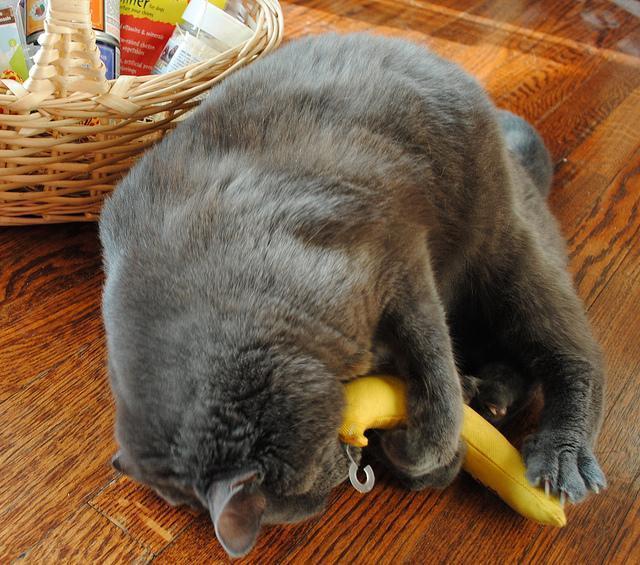How many cats can you see?
Give a very brief answer. 1. How many people have their hair down?
Give a very brief answer. 0. 